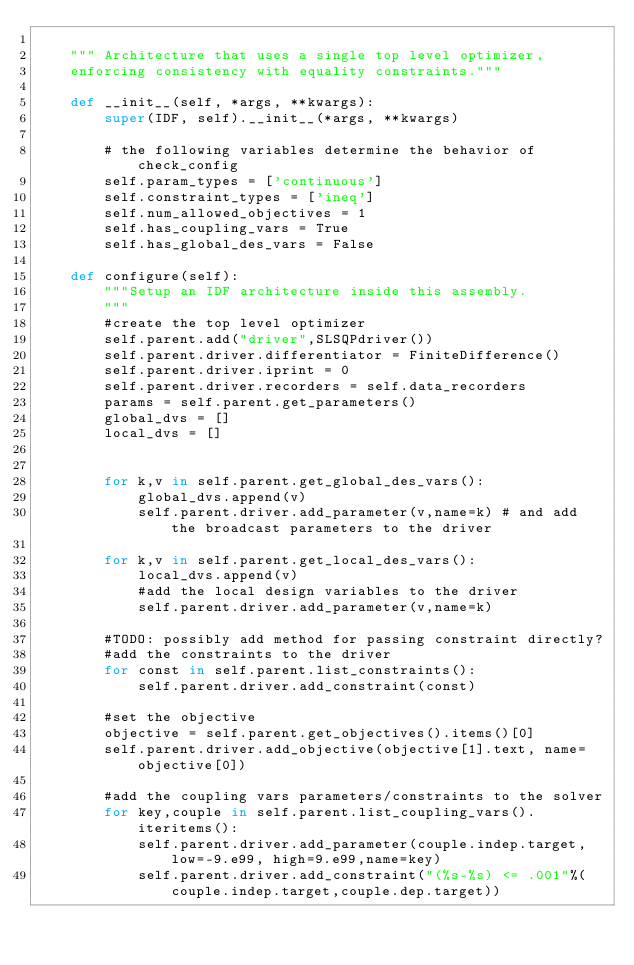<code> <loc_0><loc_0><loc_500><loc_500><_Python_>    
    """ Architecture that uses a single top level optimizer, 
    enforcing consistency with equality constraints."""
    
    def __init__(self, *args, **kwargs):
        super(IDF, self).__init__(*args, **kwargs)
        
        # the following variables determine the behavior of check_config
        self.param_types = ['continuous']
        self.constraint_types = ['ineq']
        self.num_allowed_objectives = 1
        self.has_coupling_vars = True
        self.has_global_des_vars = False
    
    def configure(self): 
        """Setup an IDF architecture inside this assembly.
        """
        #create the top level optimizer
        self.parent.add("driver",SLSQPdriver())
        self.parent.driver.differentiator = FiniteDifference()
        self.parent.driver.iprint = 0
        self.parent.driver.recorders = self.data_recorders
        params = self.parent.get_parameters()
        global_dvs = []
        local_dvs = []
        

        for k,v in self.parent.get_global_des_vars(): 
            global_dvs.append(v)
            self.parent.driver.add_parameter(v,name=k) # and add the broadcast parameters to the driver
        
        for k,v in self.parent.get_local_des_vars(): 
            local_dvs.append(v)
            #add the local design variables to the driver
            self.parent.driver.add_parameter(v,name=k)

        #TODO: possibly add method for passing constraint directly?
        #add the constraints to the driver
        for const in self.parent.list_constraints(): 
            self.parent.driver.add_constraint(const)
            
        #set the objective
        objective = self.parent.get_objectives().items()[0]
        self.parent.driver.add_objective(objective[1].text, name=objective[0])
        
        #add the coupling vars parameters/constraints to the solver
        for key,couple in self.parent.list_coupling_vars().iteritems(): 
            self.parent.driver.add_parameter(couple.indep.target, low=-9.e99, high=9.e99,name=key)
            self.parent.driver.add_constraint("(%s-%s) <= .001"%(couple.indep.target,couple.dep.target))</code> 